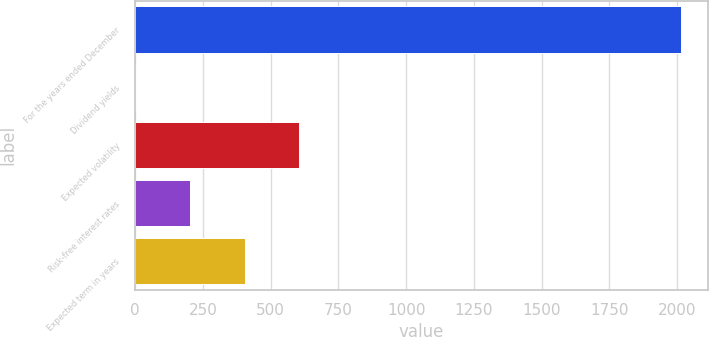Convert chart to OTSL. <chart><loc_0><loc_0><loc_500><loc_500><bar_chart><fcel>For the years ended December<fcel>Dividend yields<fcel>Expected volatility<fcel>Risk-free interest rates<fcel>Expected term in years<nl><fcel>2014<fcel>2<fcel>605.6<fcel>203.2<fcel>404.4<nl></chart> 